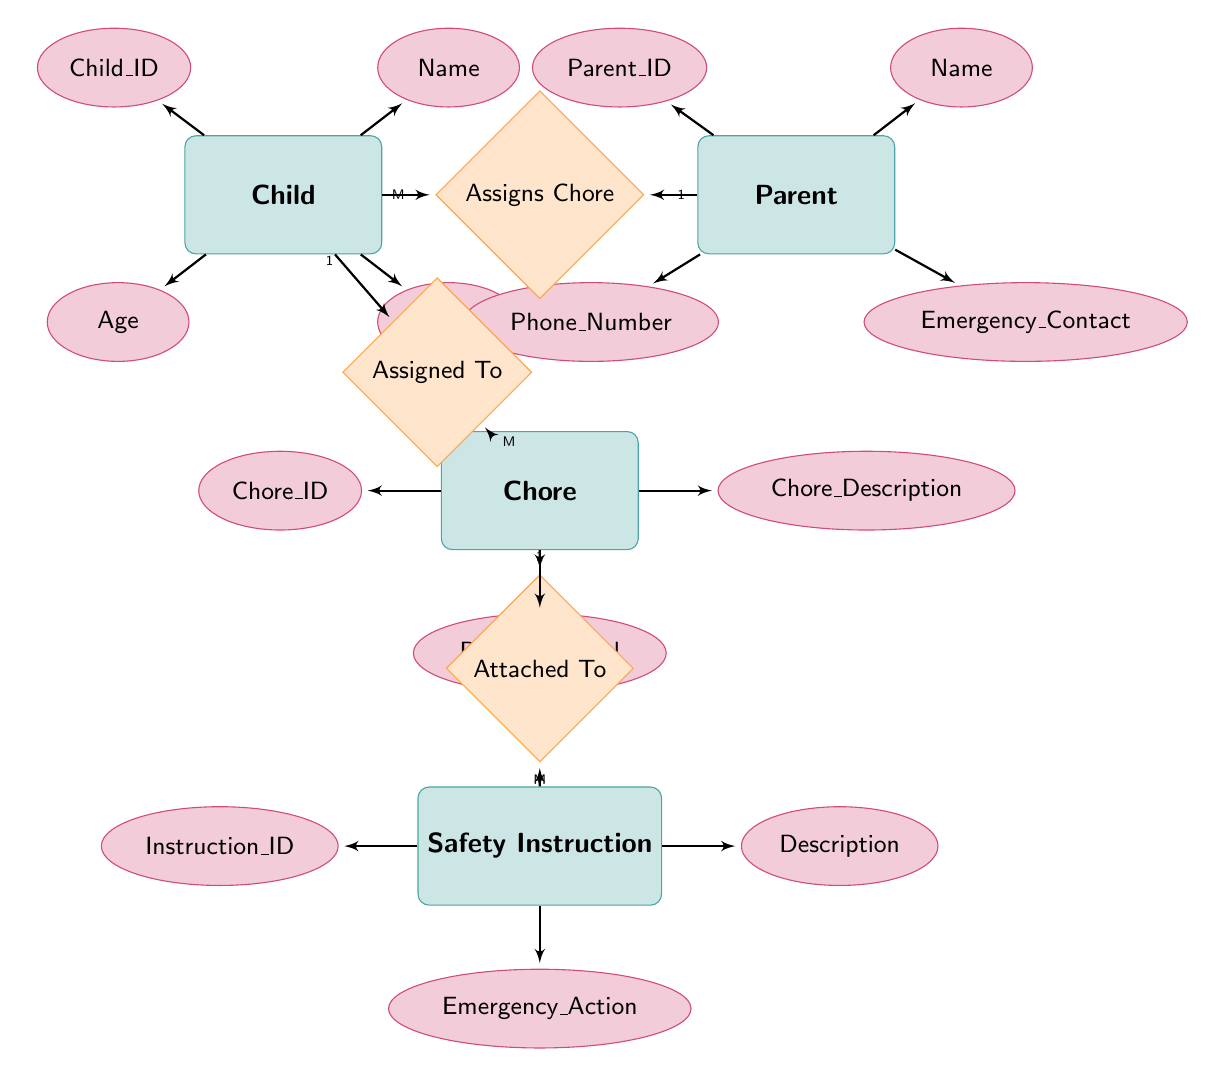What is the ID of the Child entity? The ID of the Child entity is found under its attributes section. On the diagram, the attribute named "Child_ID" represents this information.
Answer: Child_ID What is the relationship between Parent and Chore? The relationship between Parent and Chore is represented by the diamond labeled "Assigns Chore" connecting both entities. According to the relationship cardinality, one Parent can assign multiple Chores.
Answer: Assigns Chore How many attributes does the Chore entity have? The Chore entity has three attributes listed namely "Chore_ID", "Chore_Description", and "Difficulty_Level". Therefore, by directly counting them, we find that there are three attributes.
Answer: 3 What is the relationship between Chore and Safety Instruction? The relationship between Chore and Safety Instruction is indicated by the "Attached To" relationship in the diagram. It shows that one Chore can have multiple Safety Instructions associated with it.
Answer: Attached To How many Children can be assigned to a single Chore? The diagram shows that each Chore can be assigned to multiple Children, as indicated by the cardinality of "M" (many) next to "Assigned To". This implies that one Chore can engage several Children.
Answer: M Which attribute of Parent holds the Emergency Contact information? The Emergency Contact information is specified by the attribute named "Emergency_Contact". This is listed under the attributes section of the Parent entity.
Answer: Emergency_Contact How many Safety Instructions can be associated with a single Chore? The relationship "Attached To" indicates that one Chore can be associated with multiple Safety Instructions, as shown by the cardinality "M" next to Safety Instruction.
Answer: M What property does a Chore have related to its difficulty? A property related to the difficulty of a Chore is specified by "Difficulty_Level" in the Chore entity's attributes. This attribute defines how challenging a Chore is.
Answer: Difficulty_Level What does the Safety Instruction entity contain? The Safety Instruction entity contains three attributes: "Instruction_ID", "Description", and "Emergency_Action". These attributes encompass the necessary safety guidelines linked with each Chore.
Answer: Instruction_ID, Description, Emergency_Action 